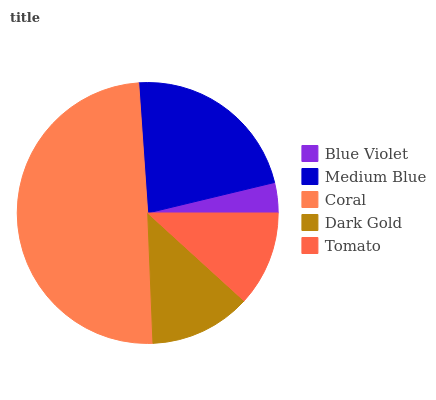Is Blue Violet the minimum?
Answer yes or no. Yes. Is Coral the maximum?
Answer yes or no. Yes. Is Medium Blue the minimum?
Answer yes or no. No. Is Medium Blue the maximum?
Answer yes or no. No. Is Medium Blue greater than Blue Violet?
Answer yes or no. Yes. Is Blue Violet less than Medium Blue?
Answer yes or no. Yes. Is Blue Violet greater than Medium Blue?
Answer yes or no. No. Is Medium Blue less than Blue Violet?
Answer yes or no. No. Is Dark Gold the high median?
Answer yes or no. Yes. Is Dark Gold the low median?
Answer yes or no. Yes. Is Blue Violet the high median?
Answer yes or no. No. Is Coral the low median?
Answer yes or no. No. 